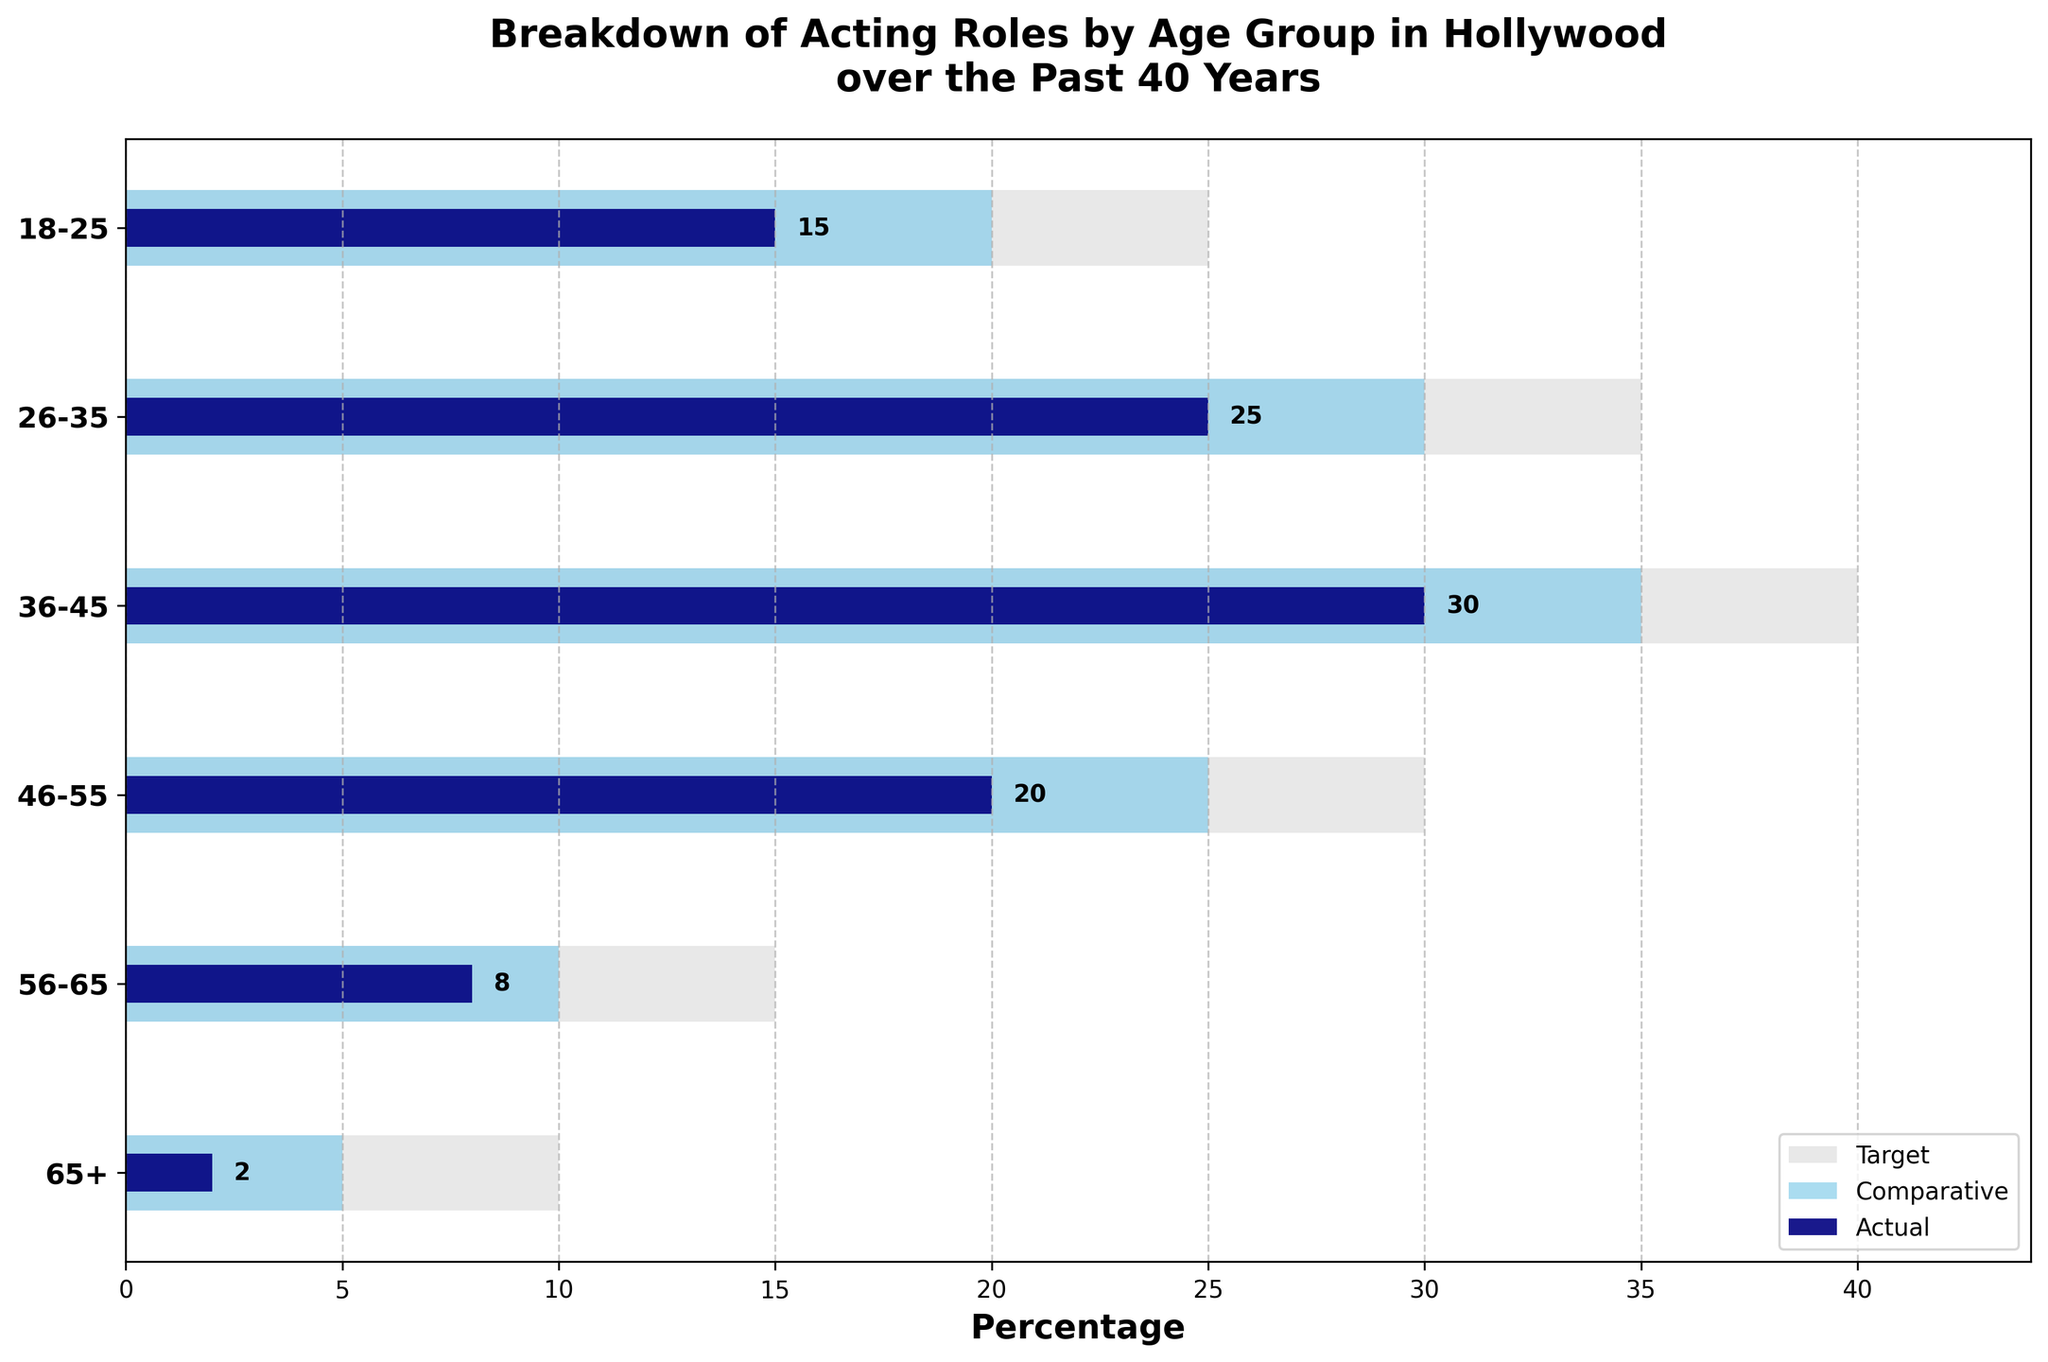What is the title of the chart? The title of the chart is usually displayed at the top of the figure. In this case, it says "Breakdown of Acting Roles by Age Group in Hollywood over the Past 40 Years".
Answer: Breakdown of Acting Roles by Age Group in Hollywood over the Past 40 Years Which age group has the highest actual percentage of acting roles? To find this, look for the longest dark navy blue bar representing the actual percentage. In this case, it is the 36-45 age group at 30%.
Answer: 36-45 How does the actual percentage of acting roles for the 18-25 age group compare to their target percentage? The actual percentage for the 18-25 age group is at 15%, while their target percentage is 25%. The actual percentage is 10% lower than the target.
Answer: 10% lower What is the comparative percentage of acting roles for the 65+ age group? The comparative percentage is depicted by the sky blue bar. For the 65+ age group, it is 5%.
Answer: 5% How many age groups have an actual percentage that is greater than their comparative percentage? Compare the lengths of the dark navy blue bars (actual) with the sky blue bars (comparative) in each age group. Only the 26-35 and the 36-45 age groups have actual percentages greater than their comparative percentages.
Answer: 2 Is there any age group where the target percentage is the same as the comparative percentage? Since the target percentages are represented by light grey bars and the comparative percentages by sky blue bars, you can compare their lengths. None of the age groups have the same target and comparative percentages.
Answer: No What can you infer about the trend of acting roles as age increases? By examining the lengths of the bars from 18-25 to 65+, it is clear that the actual percentage generally decreases as age increases. This suggests fewer acting roles for older age groups.
Answer: Fewer roles for older age groups What is the total percentage of actual acting roles for age groups 46-55 and 56-65 combined? Add the actual percentages for the age groups 46-55 and 56-65, which are 20% and 8% respectively. The total is 20% + 8% = 28%.
Answer: 28% Which age group has the largest gap between its target and its actual percentage? Calculate the difference between the target and actual percentages for each age group. The largest gap is in the 65+ age group, with a target of 10% and an actual of 2% (a gap of 8%).
Answer: 65+ For which age group is the actual percentage closest to the comparative percentage? Compare the differences between the actual and comparative percentages for each age group. The closest match is the 46-55 age group, where the actual is 20% and the comparative is 25%, making a difference of 5%.
Answer: 46-55 